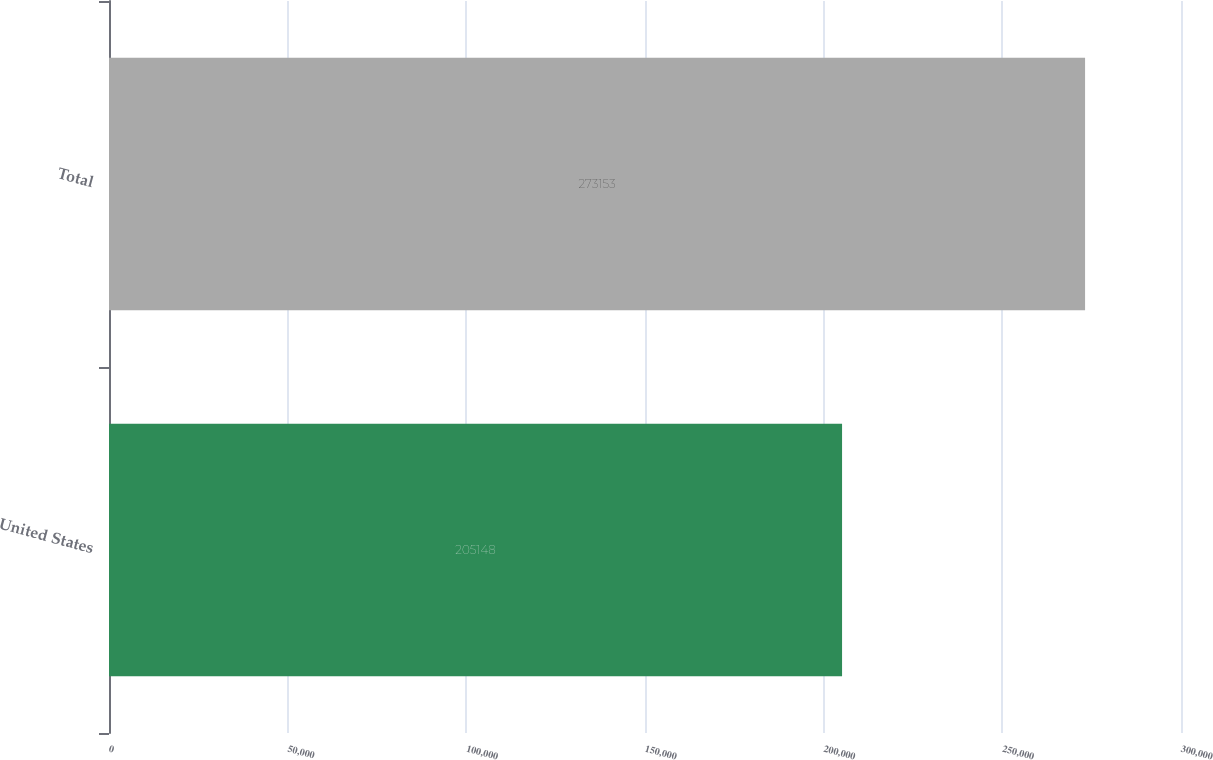<chart> <loc_0><loc_0><loc_500><loc_500><bar_chart><fcel>United States<fcel>Total<nl><fcel>205148<fcel>273153<nl></chart> 